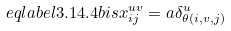Convert formula to latex. <formula><loc_0><loc_0><loc_500><loc_500>\ e q l a b e l { 3 . 1 4 . 4 b i s } x ^ { u v } _ { i j } = a \delta ^ { u } _ { \theta ( i , v , j ) }</formula> 